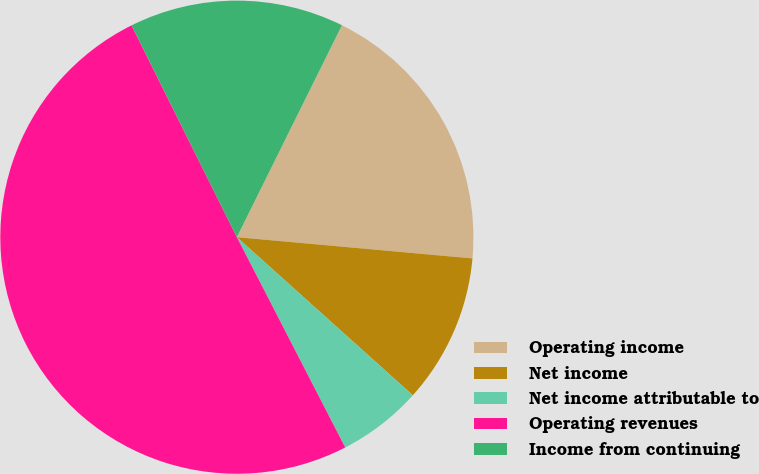<chart> <loc_0><loc_0><loc_500><loc_500><pie_chart><fcel>Operating income<fcel>Net income<fcel>Net income attributable to<fcel>Operating revenues<fcel>Income from continuing<nl><fcel>19.11%<fcel>10.22%<fcel>5.78%<fcel>50.23%<fcel>14.67%<nl></chart> 